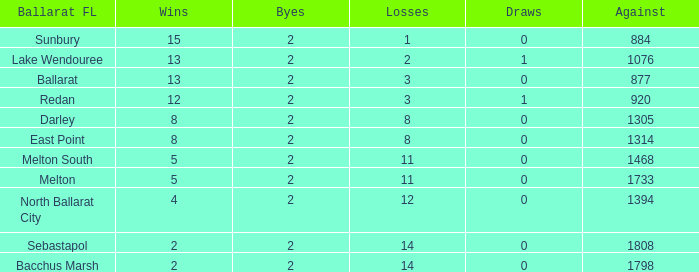How many Against has Byes smaller than 2? None. 